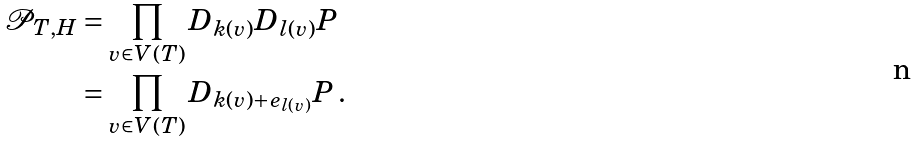<formula> <loc_0><loc_0><loc_500><loc_500>\mathcal { P } _ { T , H } & = \prod _ { v \in V ( T ) } D _ { k ( v ) } D _ { l ( v ) } P \\ & = \prod _ { v \in V ( T ) } D _ { k ( v ) + e _ { l ( v ) } } P \, .</formula> 